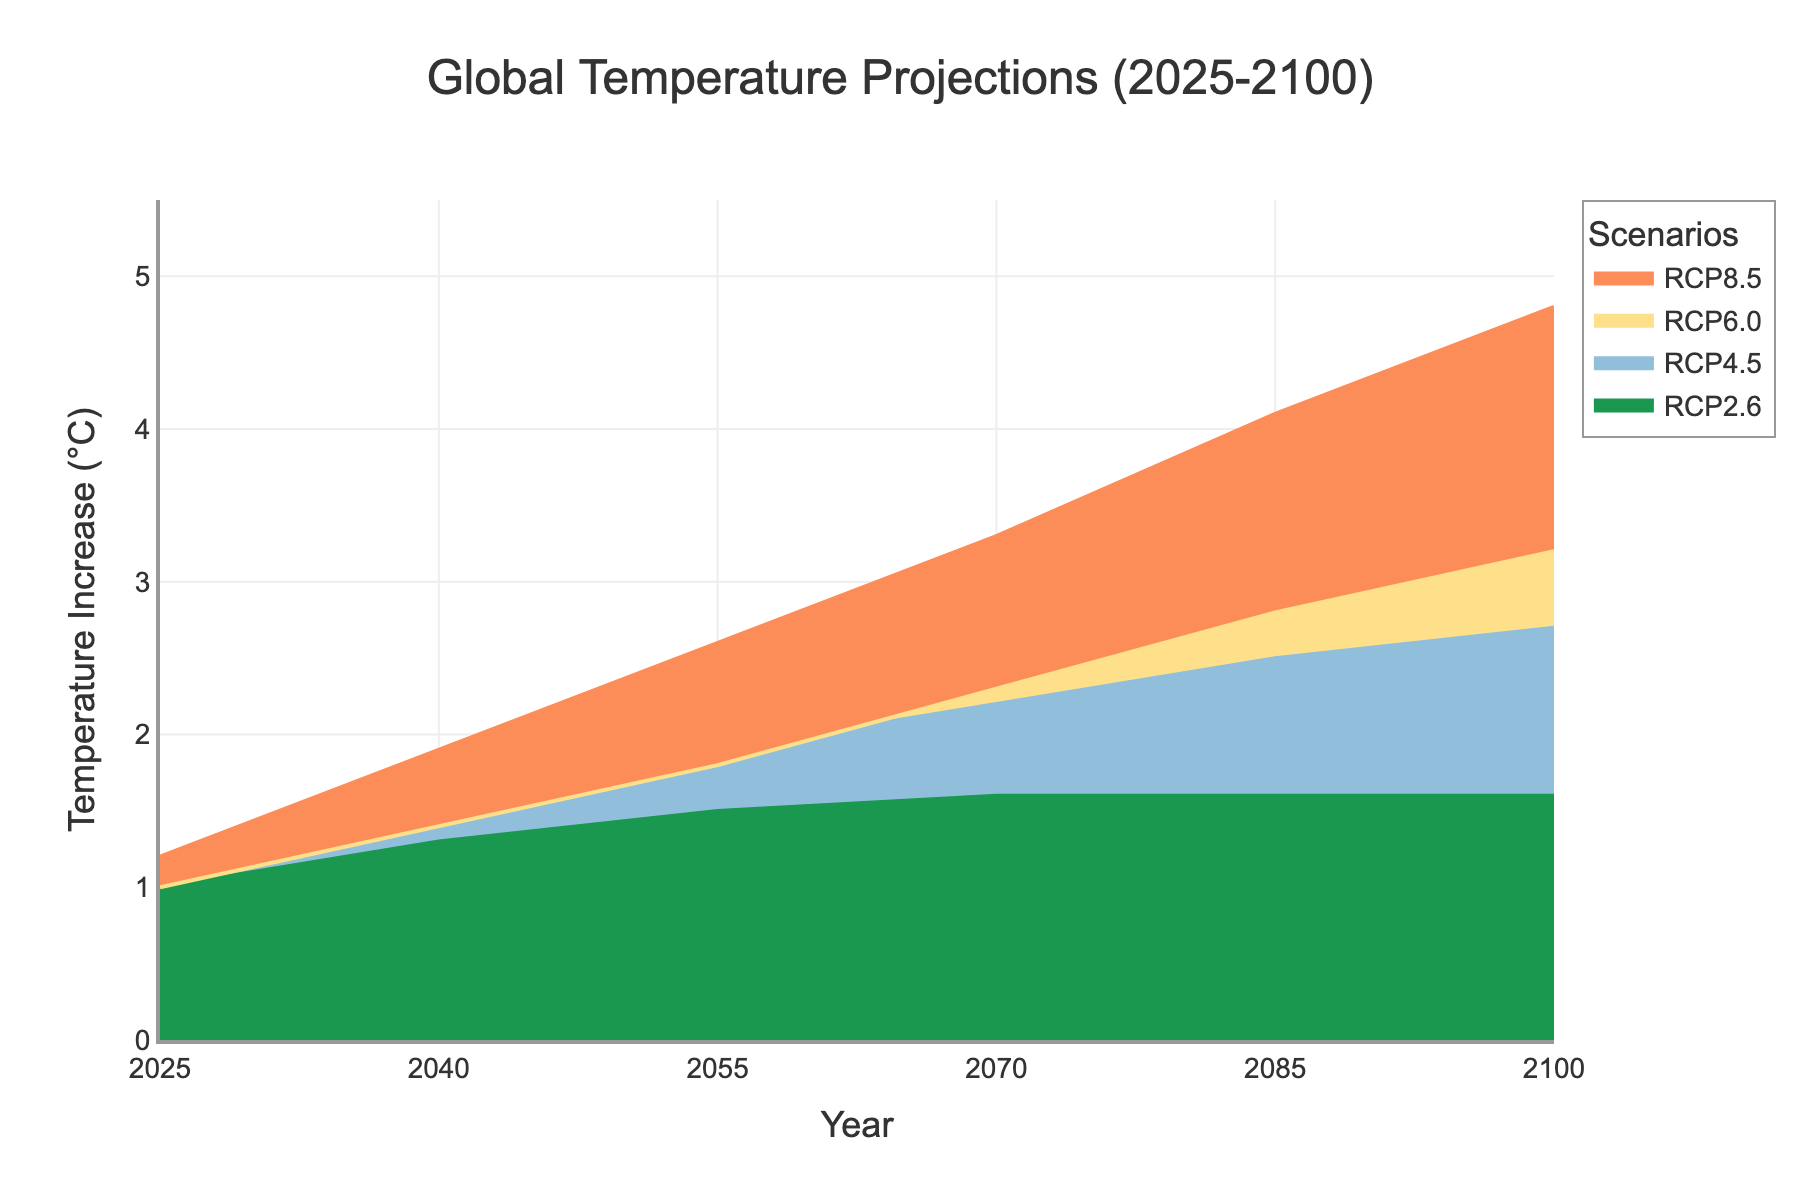What is the title of the figure? The title of a figure is usually at the top center and in larger font. In this case, the title is clearly stated as "Global Temperature Projections (2025-2100)".
Answer: Global Temperature Projections (2025-2100) What is the predicted temperature increase in 2040 under the RCP8.5 scenario? Locate the year 2040 on the x-axis, then find the corresponding value for the RCP8.5 scenario on the y-axis. The figure shows this value as 1.9°C.
Answer: 1.9°C Which scenario shows the smallest temperature increase by 2100? To determine this, look at the y-values for all scenarios at the year 2100. The RCP2.6 scenario has the smallest increase, which is 1.6°C.
Answer: RCP2.6 By how much is the temperature increase projected to be higher under RCP8.5 compared to RCP4.5 in 2070? Find the temperature increase for both RCP8.5 and RCP4.5 at the year 2070. Subtract the RCP4.5 increase (2.2°C) from the RCP8.5 increase (3.3°C). The difference is 3.3 - 2.2 = 1.1°C.
Answer: 1.1°C What is the trend of temperature increase over time for the RCP6.0 scenario? For the RCP6.0 scenario, observe the slope of the line from 2025 to 2100. The trend indicates a steady increase from 1.0°C in 2025 to 3.2°C in 2100.
Answer: Increasing trend Is there any scenario where the temperature increase levels off after a certain year? Examine the lines representing each scenario. The RCP2.6 scenario shows an increase that levels off and remains constant from 2085 to 2100 at 1.6°C.
Answer: Yes, RCP2.6 Which scenario shows the highest temperature increase in 2055? Locate the year 2055 and compare the y-values for all scenarios. The RCP8.5 scenario has the highest increase at 2.6°C.
Answer: RCP8.5 How does the range of temperature increase predictions vary between 2025 and 2100? Notice the spread of the y-values from different scenarios for 2025 and for 2100. In 2025, the range is from 1.0°C to 1.2°C. In 2100, the range is from 1.6°C to 4.8°C.
Answer: Range in 2025: 0.2°C, Range in 2100: 3.2°C What color represents the RCP4.5 scenario on the plot? Identify the color associated with the RCP4.5 line on the plot. It is light blue.
Answer: Light blue 